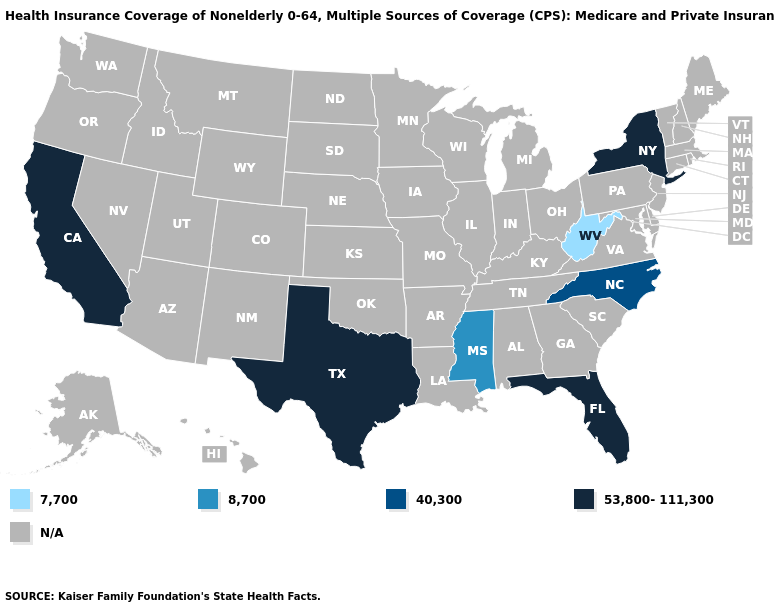What is the value of Virginia?
Answer briefly. N/A. What is the lowest value in the South?
Answer briefly. 7,700. Does the map have missing data?
Keep it brief. Yes. Name the states that have a value in the range 7,700?
Give a very brief answer. West Virginia. What is the lowest value in the USA?
Give a very brief answer. 7,700. What is the value of Missouri?
Quick response, please. N/A. What is the value of New Hampshire?
Write a very short answer. N/A. Does West Virginia have the lowest value in the USA?
Concise answer only. Yes. Among the states that border Kentucky , which have the highest value?
Concise answer only. West Virginia. Name the states that have a value in the range 7,700?
Answer briefly. West Virginia. Which states have the highest value in the USA?
Quick response, please. California, Florida, New York, Texas. What is the value of Florida?
Keep it brief. 53,800-111,300. 